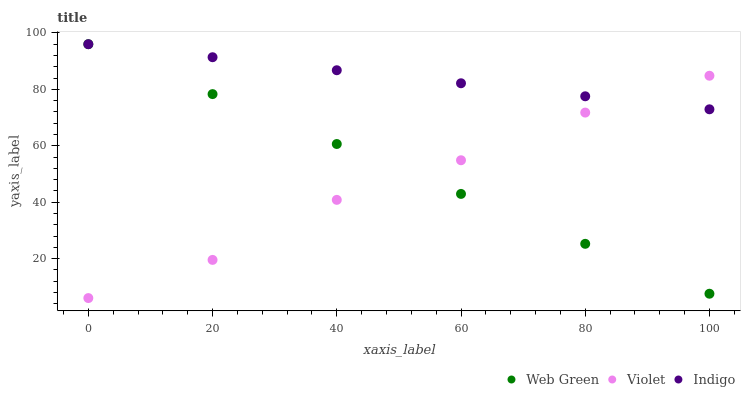Does Violet have the minimum area under the curve?
Answer yes or no. Yes. Does Indigo have the maximum area under the curve?
Answer yes or no. Yes. Does Web Green have the minimum area under the curve?
Answer yes or no. No. Does Web Green have the maximum area under the curve?
Answer yes or no. No. Is Web Green the smoothest?
Answer yes or no. Yes. Is Violet the roughest?
Answer yes or no. Yes. Is Violet the smoothest?
Answer yes or no. No. Is Web Green the roughest?
Answer yes or no. No. Does Violet have the lowest value?
Answer yes or no. Yes. Does Web Green have the lowest value?
Answer yes or no. No. Does Web Green have the highest value?
Answer yes or no. Yes. Does Violet have the highest value?
Answer yes or no. No. Does Web Green intersect Violet?
Answer yes or no. Yes. Is Web Green less than Violet?
Answer yes or no. No. Is Web Green greater than Violet?
Answer yes or no. No. 